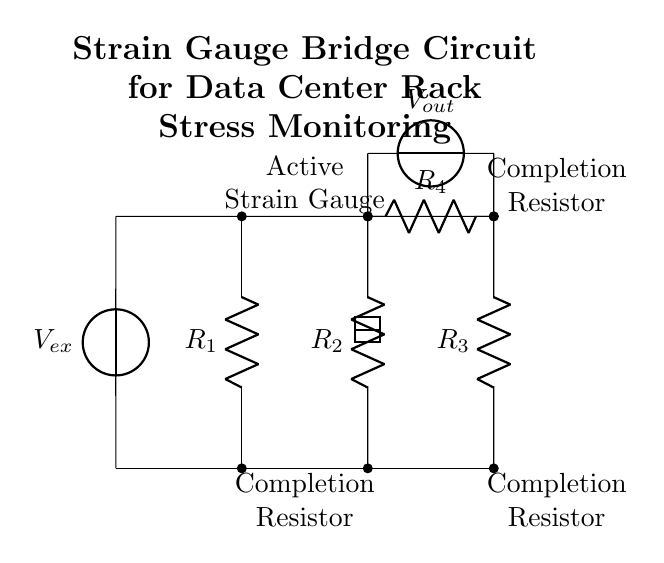What is the power source in this circuit? The power source in this circuit is labeled as \( V_{ex} \), which is connected to both the top and bottom of the bridge circuit, providing a potential difference needed for operation.
Answer: \( V_{ex} \) How many resistors are present in the strain gauge bridge circuit? The circuit diagram shows four resistors, which are labeled \( R_1 \), \( R_2 \), \( R_3 \), and \( R_4 \). These form the components of the bridge configuration.
Answer: Four What does \( V_{out} \) represent in this circuit? \( V_{out} \) represents the output voltage of the bridge circuit, which indicates the change in voltage due to the difference in resistance caused by strain in the gauge.
Answer: Output voltage Which component is the active strain gauge? The active strain gauge is indicated by a rectangular symbol within the circuit diagram, specifically positioned between resistors \( R_1 \) and \( R_2 \).
Answer: Active strain gauge What is the purpose of the completion resistors? The completion resistors, which are not labeled but understood to be in the configuration, help balance and stabilize the bridge circuit to accurately measure changes in resistance.
Answer: Balance and stabilization What would happen if one of the resistors in the bridge fails? If one of the resistors fails, it would unbalance the bridge resulting in an incorrect output voltage \( V_{out} \), making the readings unreliable for stress measurement.
Answer: Unbalance in the bridge What type of circuit configuration is used in this strain gauge setup? This circuit follows a bridge configuration, specifically a Wheatstone bridge type, designed for precise measurement of small changes in resistance due to strain.
Answer: Bridge configuration 